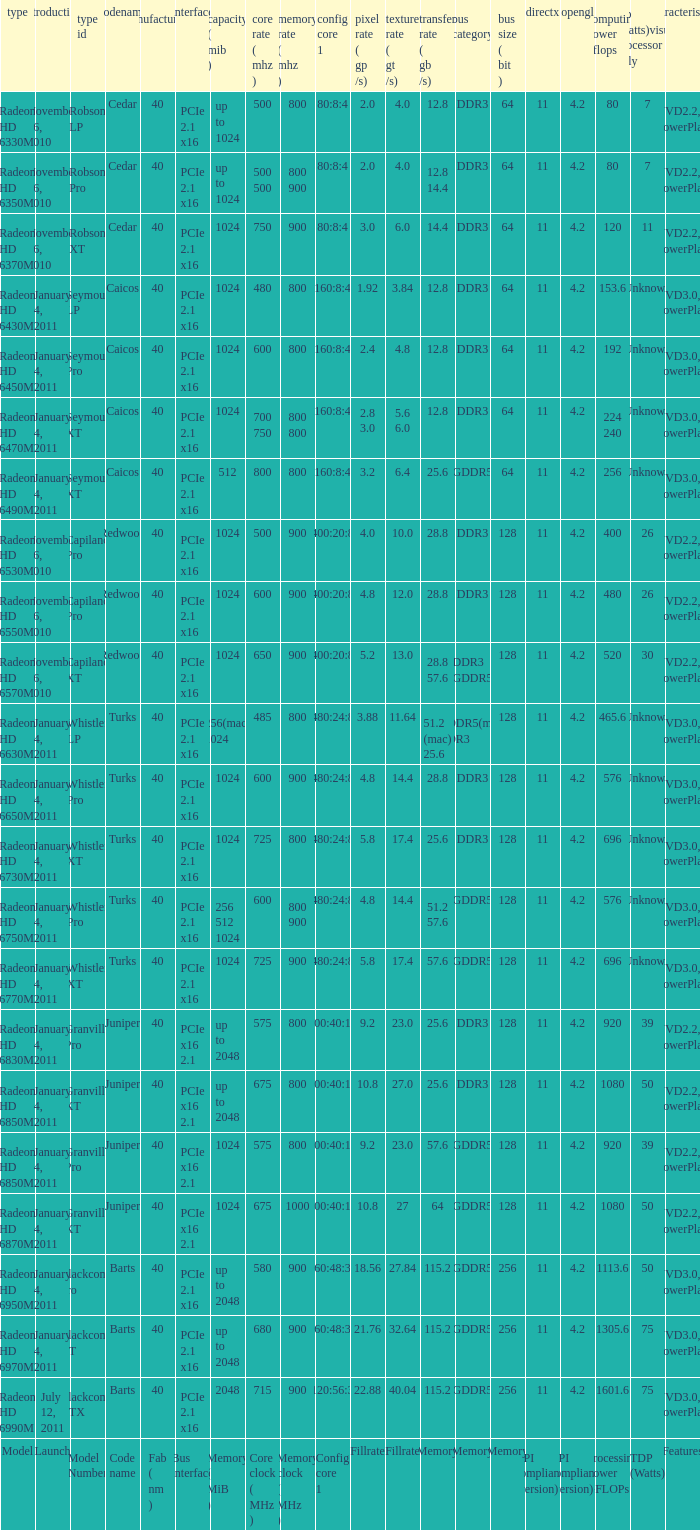What is the number of values for fab(nm) when the model number is whistler lp? 1.0. 